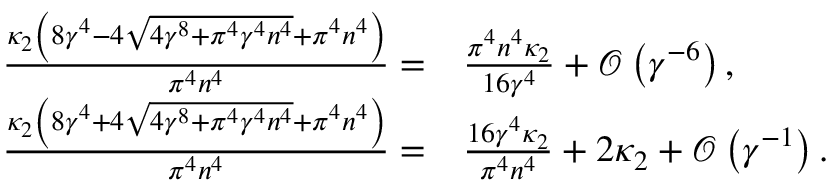Convert formula to latex. <formula><loc_0><loc_0><loc_500><loc_500>\begin{array} { r l } { \frac { \kappa _ { 2 } \left ( 8 \gamma ^ { 4 } - 4 \sqrt { 4 \gamma ^ { 8 } + \pi ^ { 4 } \gamma ^ { 4 } n ^ { 4 } } + \pi ^ { 4 } n ^ { 4 } \right ) } { \pi ^ { 4 } n ^ { 4 } } = } & \frac { \pi ^ { 4 } n ^ { 4 } \kappa _ { 2 } } { 1 6 \gamma ^ { 4 } } + \mathcal { O } \left ( \gamma ^ { - 6 } \right ) , } \\ { \frac { \kappa _ { 2 } \left ( 8 \gamma ^ { 4 } + 4 \sqrt { 4 \gamma ^ { 8 } + \pi ^ { 4 } \gamma ^ { 4 } n ^ { 4 } } + \pi ^ { 4 } n ^ { 4 } \right ) } { \pi ^ { 4 } n ^ { 4 } } = } & \frac { 1 6 \gamma ^ { 4 } \kappa _ { 2 } } { \pi ^ { 4 } n ^ { 4 } } + 2 \kappa _ { 2 } + \mathcal { O } \left ( \gamma ^ { - 1 } \right ) . } \end{array}</formula> 